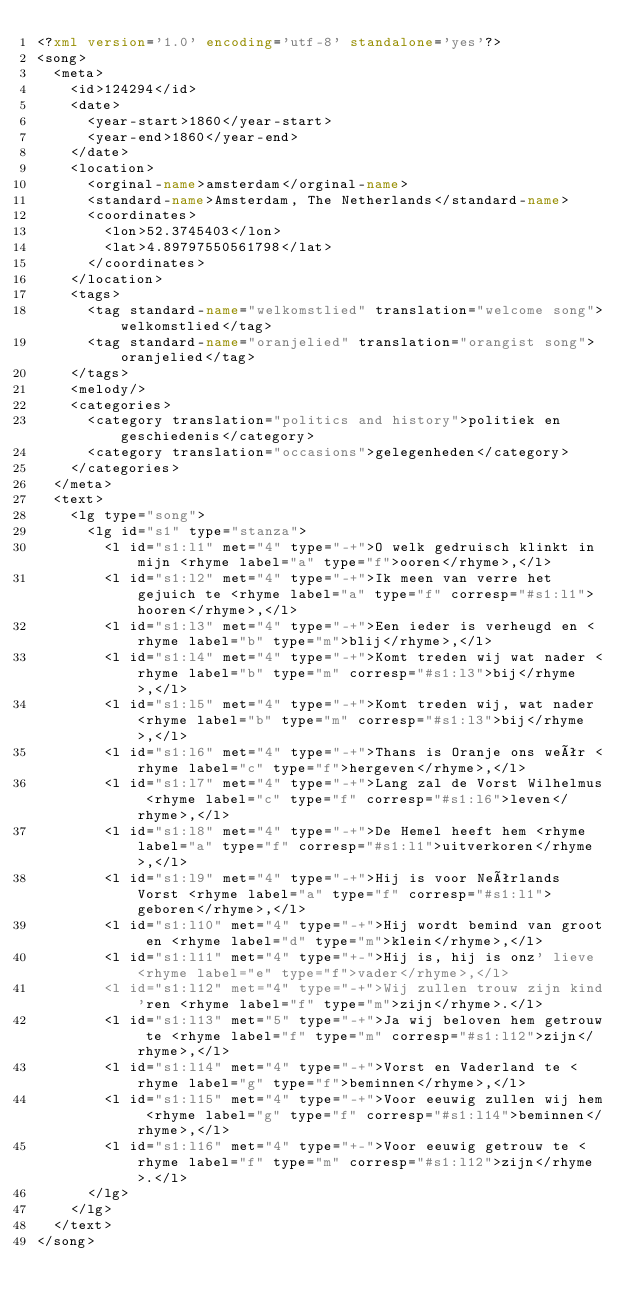<code> <loc_0><loc_0><loc_500><loc_500><_XML_><?xml version='1.0' encoding='utf-8' standalone='yes'?>
<song>
  <meta>
    <id>124294</id>
    <date>
      <year-start>1860</year-start>
      <year-end>1860</year-end>
    </date>
    <location>
      <orginal-name>amsterdam</orginal-name>
      <standard-name>Amsterdam, The Netherlands</standard-name>
      <coordinates>
        <lon>52.3745403</lon>
        <lat>4.89797550561798</lat>
      </coordinates>
    </location>
    <tags>
      <tag standard-name="welkomstlied" translation="welcome song">welkomstlied</tag>
      <tag standard-name="oranjelied" translation="orangist song">oranjelied</tag>
    </tags>
    <melody/>
    <categories>
      <category translation="politics and history">politiek en geschiedenis</category>
      <category translation="occasions">gelegenheden</category>
    </categories>
  </meta>
  <text>
    <lg type="song">
      <lg id="s1" type="stanza">
        <l id="s1:l1" met="4" type="-+">O welk gedruisch klinkt in mijn <rhyme label="a" type="f">ooren</rhyme>,</l>
        <l id="s1:l2" met="4" type="-+">Ik meen van verre het gejuich te <rhyme label="a" type="f" corresp="#s1:l1">hooren</rhyme>,</l>
        <l id="s1:l3" met="4" type="-+">Een ieder is verheugd en <rhyme label="b" type="m">blij</rhyme>,</l>
        <l id="s1:l4" met="4" type="-+">Komt treden wij wat nader <rhyme label="b" type="m" corresp="#s1:l3">bij</rhyme>,</l>
        <l id="s1:l5" met="4" type="-+">Komt treden wij, wat nader <rhyme label="b" type="m" corresp="#s1:l3">bij</rhyme>,</l>
        <l id="s1:l6" met="4" type="-+">Thans is Oranje ons weêr <rhyme label="c" type="f">hergeven</rhyme>,</l>
        <l id="s1:l7" met="4" type="-+">Lang zal de Vorst Wilhelmus <rhyme label="c" type="f" corresp="#s1:l6">leven</rhyme>,</l>
        <l id="s1:l8" met="4" type="-+">De Hemel heeft hem <rhyme label="a" type="f" corresp="#s1:l1">uitverkoren</rhyme>,</l>
        <l id="s1:l9" met="4" type="-+">Hij is voor Neêrlands Vorst <rhyme label="a" type="f" corresp="#s1:l1">geboren</rhyme>,</l>
        <l id="s1:l10" met="4" type="-+">Hij wordt bemind van groot en <rhyme label="d" type="m">klein</rhyme>,</l>
        <l id="s1:l11" met="4" type="+-">Hij is, hij is onz' lieve <rhyme label="e" type="f">vader</rhyme>,</l>
        <l id="s1:l12" met="4" type="-+">Wij zullen trouw zijn kind'ren <rhyme label="f" type="m">zijn</rhyme>.</l>
        <l id="s1:l13" met="5" type="-+">Ja wij beloven hem getrouw te <rhyme label="f" type="m" corresp="#s1:l12">zijn</rhyme>,</l>
        <l id="s1:l14" met="4" type="-+">Vorst en Vaderland te <rhyme label="g" type="f">beminnen</rhyme>,</l>
        <l id="s1:l15" met="4" type="-+">Voor eeuwig zullen wij hem <rhyme label="g" type="f" corresp="#s1:l14">beminnen</rhyme>,</l>
        <l id="s1:l16" met="4" type="+-">Voor eeuwig getrouw te <rhyme label="f" type="m" corresp="#s1:l12">zijn</rhyme>.</l>
      </lg>
    </lg>
  </text>
</song>
</code> 